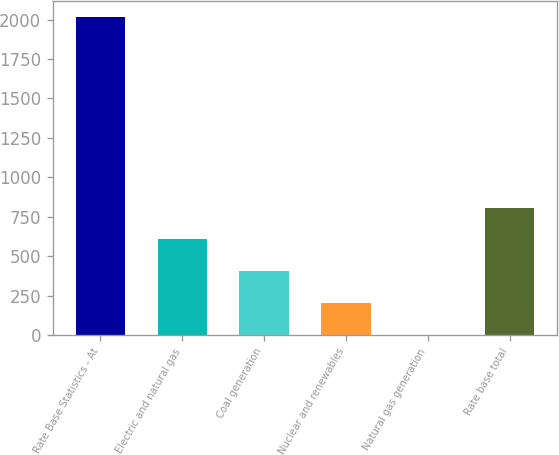<chart> <loc_0><loc_0><loc_500><loc_500><bar_chart><fcel>Rate Base Statistics - At<fcel>Electric and natural gas<fcel>Coal generation<fcel>Nuclear and renewables<fcel>Natural gas generation<fcel>Rate base total<nl><fcel>2018<fcel>605.68<fcel>403.92<fcel>202.16<fcel>0.4<fcel>807.44<nl></chart> 